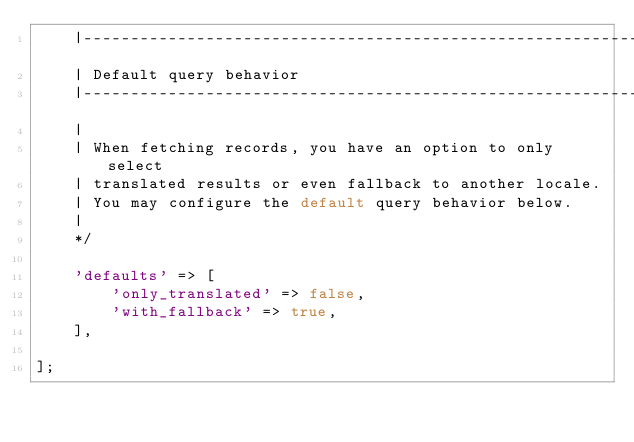<code> <loc_0><loc_0><loc_500><loc_500><_PHP_>    |-----------------------------------------------------------
    | Default query behavior
    |-----------------------------------------------------------
    |
    | When fetching records, you have an option to only select
    | translated results or even fallback to another locale.
    | You may configure the default query behavior below.
    |
    */

    'defaults' => [
        'only_translated' => false,
        'with_fallback' => true,
    ],

];
</code> 